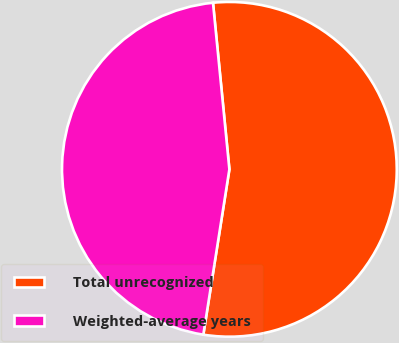Convert chart. <chart><loc_0><loc_0><loc_500><loc_500><pie_chart><fcel>Total unrecognized<fcel>Weighted-average years<nl><fcel>54.05%<fcel>45.95%<nl></chart> 